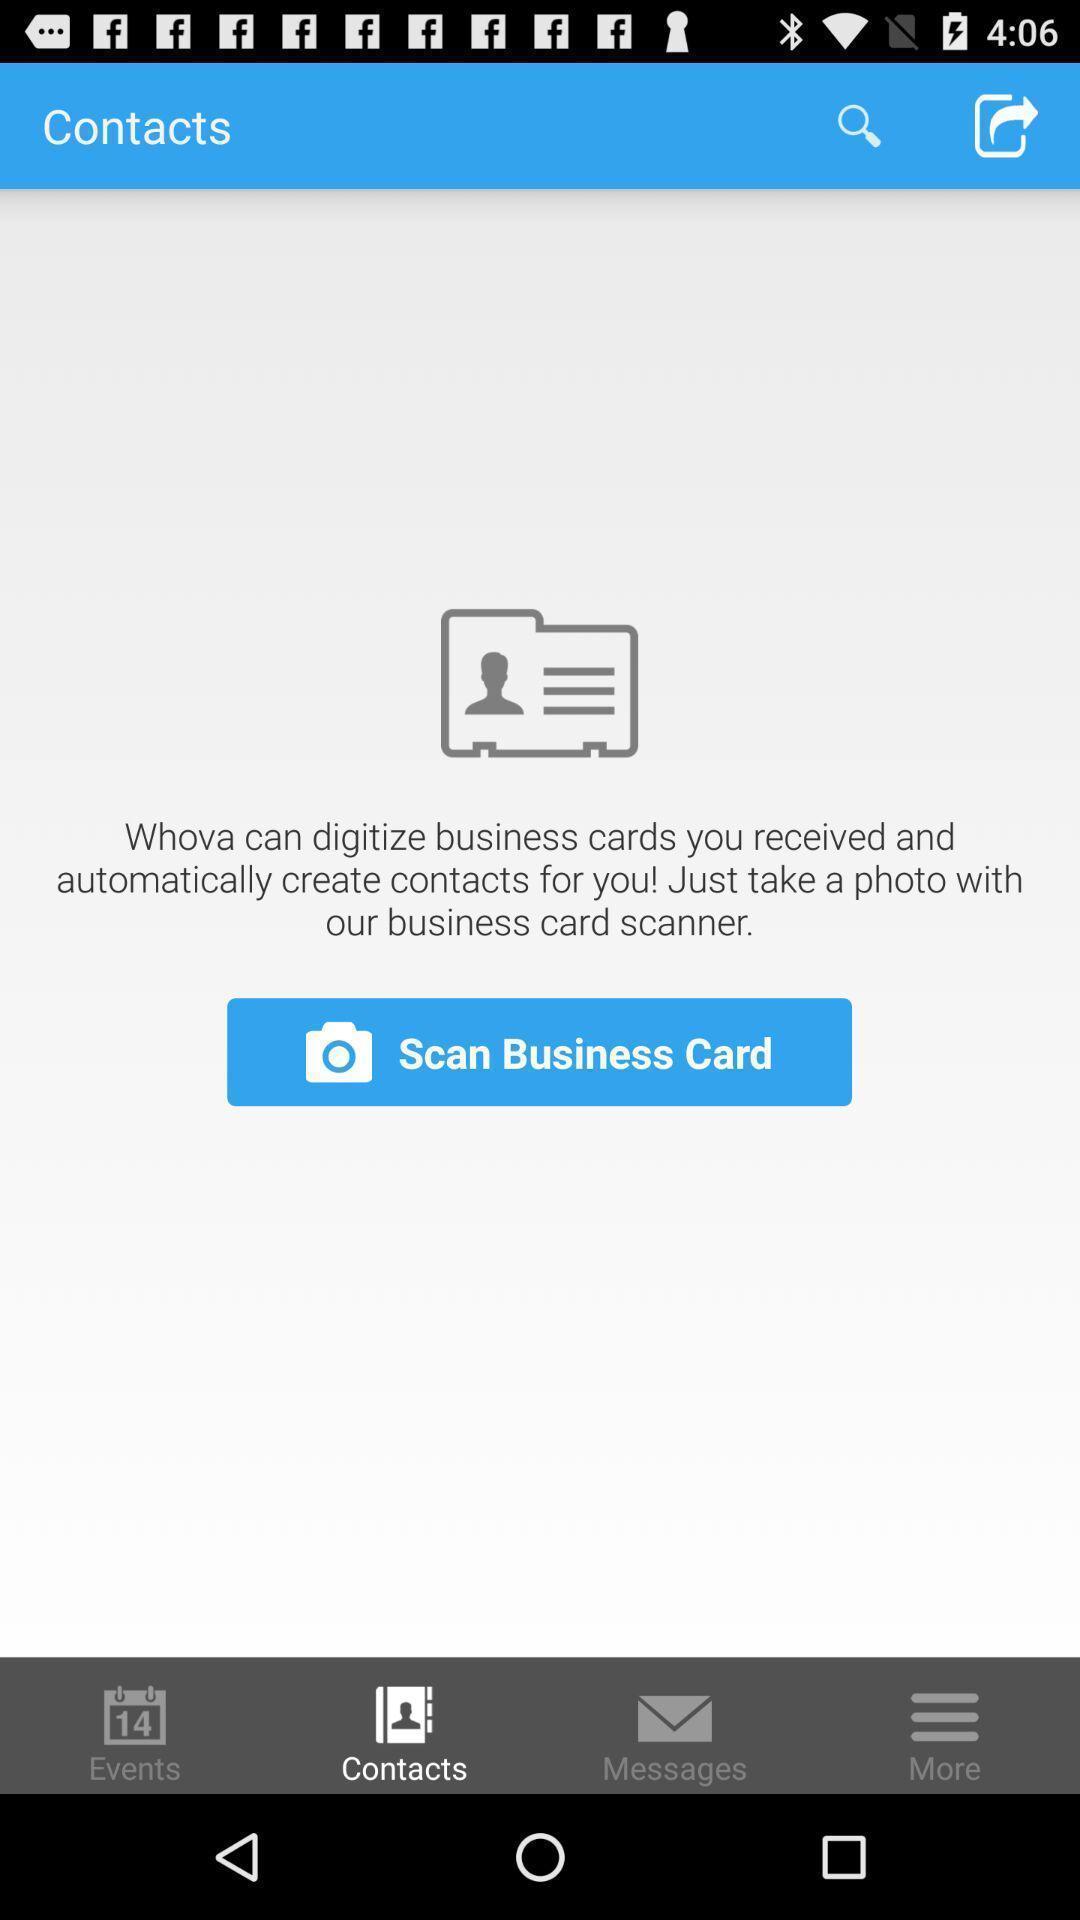Give me a narrative description of this picture. Screen displaying the contacts page. 